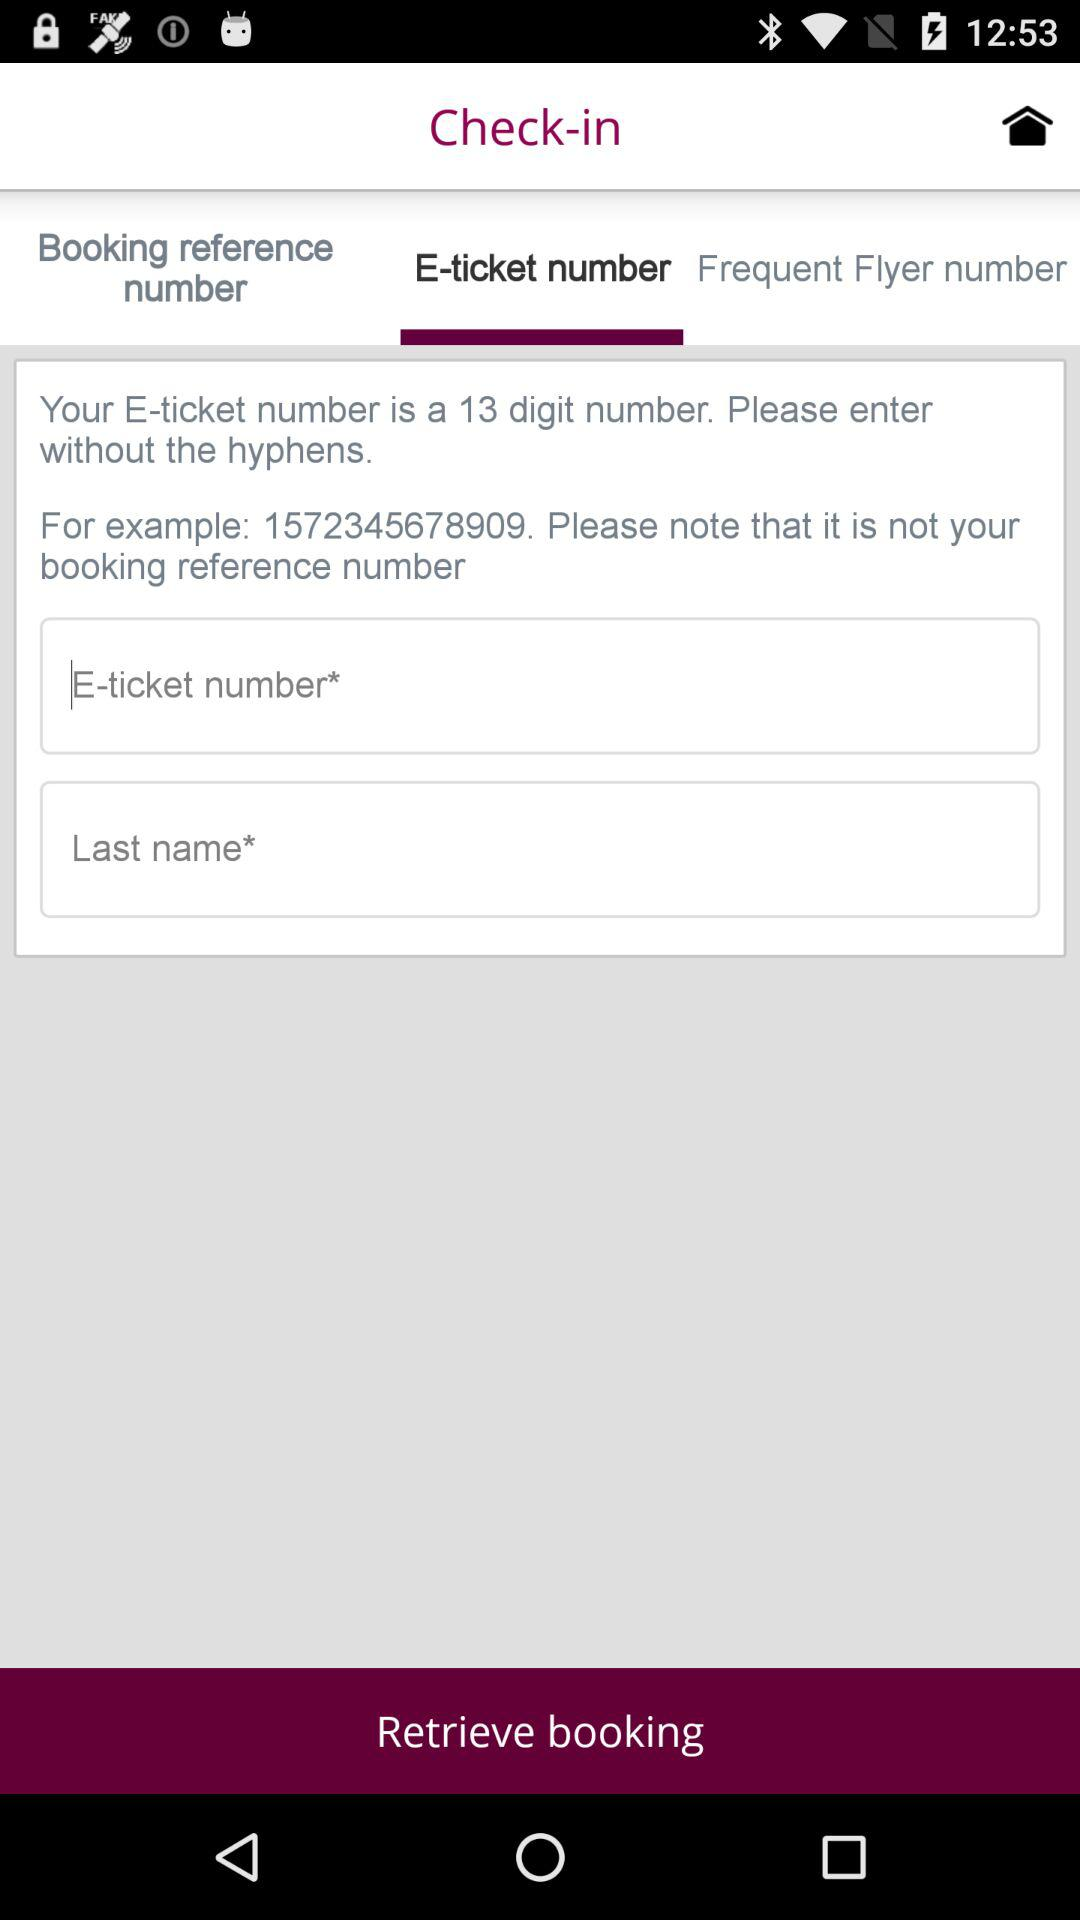What is the selected tab? The selected tab is "E-ticket number". 